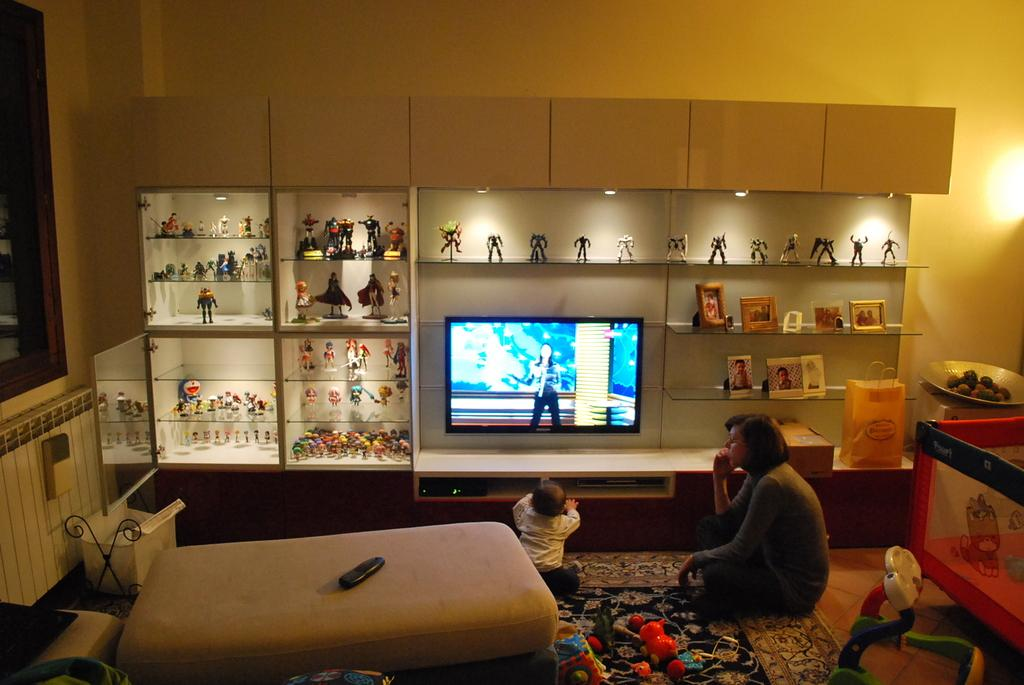Who is present in the image? There is a woman and a baby in the image. What are the woman and baby doing? The woman and baby are sitting. What are they wearing? The woman and baby are wearing clothes. What objects can be seen in the room? There is a television, carpet, floor, shelf, wall, remote, bed, and light in the image. What is the curvature of the things in the image? The question about the curvature of things in the image is not relevant, as the facts provided do not mention any specific curvature or shape of objects in the image. 